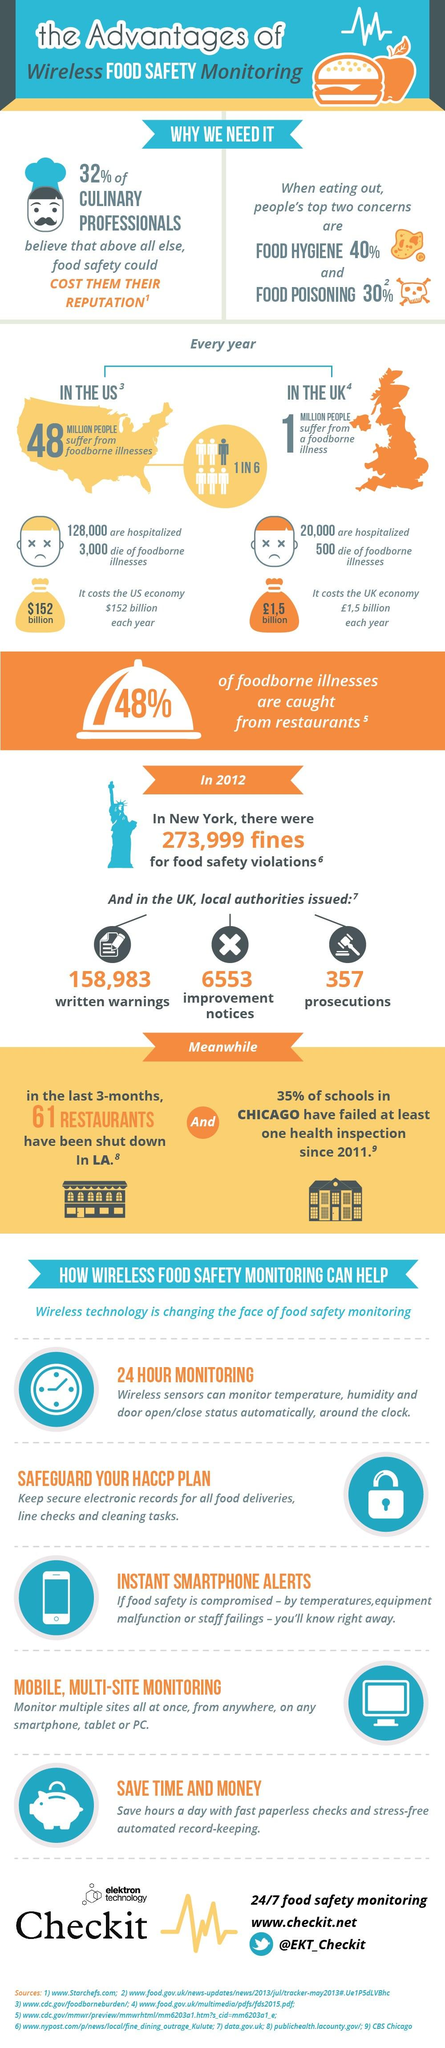Draw attention to some important aspects in this diagram. It is in the United Kingdom where a total of 357 prosecutions were issued for food safety violations. According to recent estimates, approximately 3,000 deaths are caused annually in the United States as a result of foodborne illnesses. In the United States, an estimated 48 million people, or 1 in 6, fall ill due to foodborne diseases annually. Sixty-one restaurants in the state of California were closed for failing health inspections during a three-month period. In the United Kingdom, an estimated 20,000 individuals are hospitalized annually as a result of food-related illnesses. 